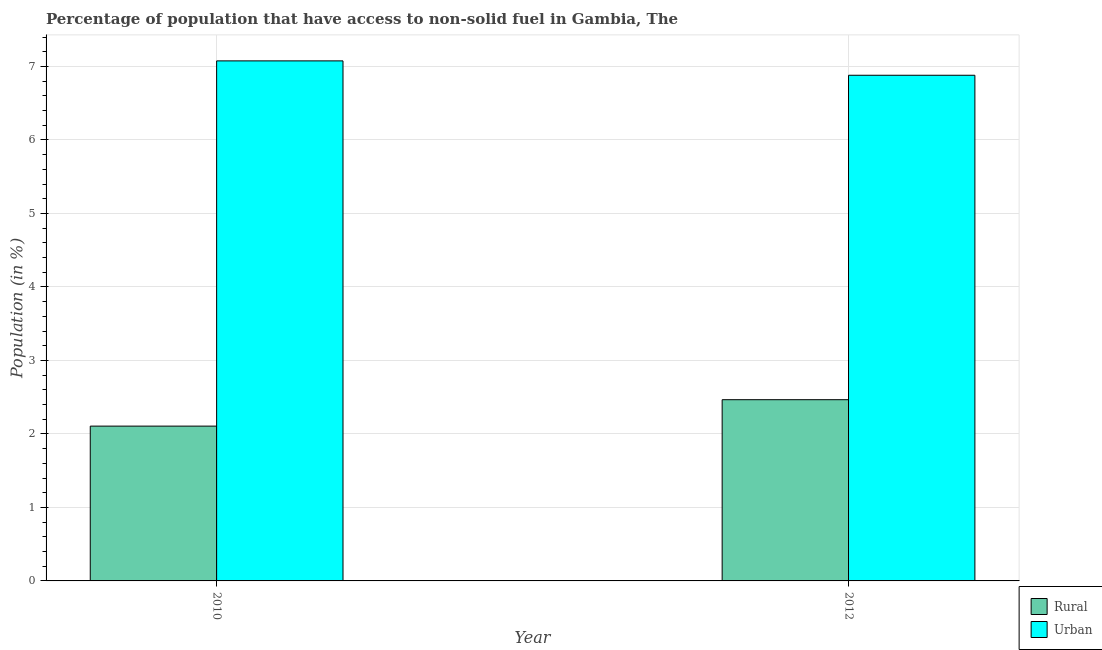How many different coloured bars are there?
Give a very brief answer. 2. Are the number of bars per tick equal to the number of legend labels?
Your answer should be very brief. Yes. How many bars are there on the 2nd tick from the left?
Your response must be concise. 2. How many bars are there on the 1st tick from the right?
Provide a short and direct response. 2. What is the rural population in 2010?
Keep it short and to the point. 2.11. Across all years, what is the maximum rural population?
Provide a succinct answer. 2.47. Across all years, what is the minimum rural population?
Your answer should be compact. 2.11. In which year was the urban population maximum?
Ensure brevity in your answer.  2010. In which year was the rural population minimum?
Provide a short and direct response. 2010. What is the total rural population in the graph?
Keep it short and to the point. 4.57. What is the difference between the urban population in 2010 and that in 2012?
Ensure brevity in your answer.  0.2. What is the difference between the urban population in 2012 and the rural population in 2010?
Offer a very short reply. -0.2. What is the average urban population per year?
Offer a very short reply. 6.98. In the year 2010, what is the difference between the rural population and urban population?
Keep it short and to the point. 0. What is the ratio of the urban population in 2010 to that in 2012?
Your answer should be compact. 1.03. Is the urban population in 2010 less than that in 2012?
Your answer should be very brief. No. What does the 1st bar from the left in 2012 represents?
Provide a short and direct response. Rural. What does the 2nd bar from the right in 2012 represents?
Ensure brevity in your answer.  Rural. How many years are there in the graph?
Keep it short and to the point. 2. What is the difference between two consecutive major ticks on the Y-axis?
Offer a very short reply. 1. Are the values on the major ticks of Y-axis written in scientific E-notation?
Provide a short and direct response. No. Does the graph contain any zero values?
Keep it short and to the point. No. Does the graph contain grids?
Ensure brevity in your answer.  Yes. How are the legend labels stacked?
Keep it short and to the point. Vertical. What is the title of the graph?
Provide a succinct answer. Percentage of population that have access to non-solid fuel in Gambia, The. Does "Nitrous oxide" appear as one of the legend labels in the graph?
Keep it short and to the point. No. What is the Population (in %) in Rural in 2010?
Your answer should be compact. 2.11. What is the Population (in %) in Urban in 2010?
Your response must be concise. 7.08. What is the Population (in %) in Rural in 2012?
Give a very brief answer. 2.47. What is the Population (in %) in Urban in 2012?
Provide a succinct answer. 6.88. Across all years, what is the maximum Population (in %) in Rural?
Your answer should be compact. 2.47. Across all years, what is the maximum Population (in %) in Urban?
Offer a terse response. 7.08. Across all years, what is the minimum Population (in %) in Rural?
Keep it short and to the point. 2.11. Across all years, what is the minimum Population (in %) in Urban?
Your response must be concise. 6.88. What is the total Population (in %) in Rural in the graph?
Make the answer very short. 4.57. What is the total Population (in %) in Urban in the graph?
Give a very brief answer. 13.96. What is the difference between the Population (in %) of Rural in 2010 and that in 2012?
Keep it short and to the point. -0.36. What is the difference between the Population (in %) in Urban in 2010 and that in 2012?
Offer a terse response. 0.2. What is the difference between the Population (in %) of Rural in 2010 and the Population (in %) of Urban in 2012?
Keep it short and to the point. -4.77. What is the average Population (in %) of Rural per year?
Your answer should be very brief. 2.29. What is the average Population (in %) of Urban per year?
Your response must be concise. 6.98. In the year 2010, what is the difference between the Population (in %) in Rural and Population (in %) in Urban?
Your response must be concise. -4.97. In the year 2012, what is the difference between the Population (in %) in Rural and Population (in %) in Urban?
Keep it short and to the point. -4.41. What is the ratio of the Population (in %) in Rural in 2010 to that in 2012?
Provide a succinct answer. 0.85. What is the ratio of the Population (in %) in Urban in 2010 to that in 2012?
Offer a terse response. 1.03. What is the difference between the highest and the second highest Population (in %) of Rural?
Give a very brief answer. 0.36. What is the difference between the highest and the second highest Population (in %) in Urban?
Offer a terse response. 0.2. What is the difference between the highest and the lowest Population (in %) of Rural?
Make the answer very short. 0.36. What is the difference between the highest and the lowest Population (in %) in Urban?
Offer a very short reply. 0.2. 